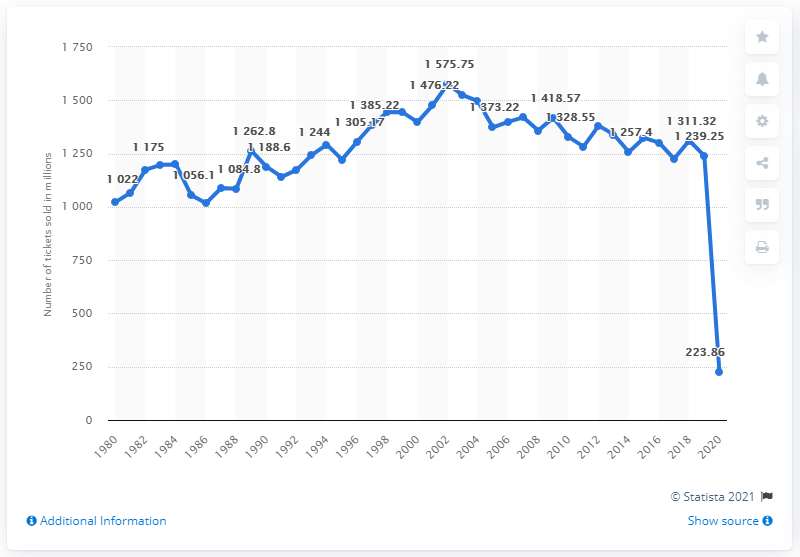Outline some significant characteristics in this image. In 2020, there were 223.86 movie admissions. 